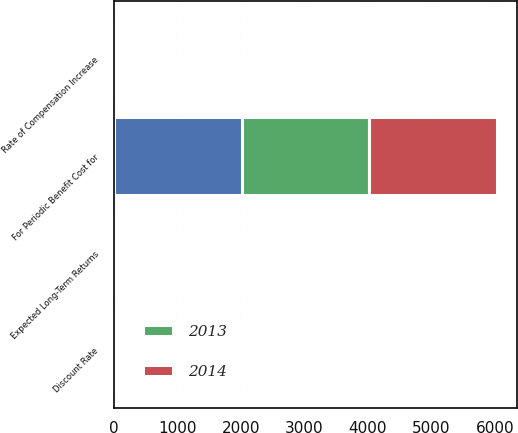Convert chart to OTSL. <chart><loc_0><loc_0><loc_500><loc_500><stacked_bar_chart><ecel><fcel>For Periodic Benefit Cost for<fcel>Discount Rate<fcel>Expected Long-Term Returns<fcel>Rate of Compensation Increase<nl><fcel>nan<fcel>2014<fcel>5.12<fcel>6.97<fcel>4.35<nl><fcel>2013<fcel>2013<fcel>4.18<fcel>6.96<fcel>4.4<nl><fcel>2014<fcel>2012<fcel>5.09<fcel>7.2<fcel>4.04<nl></chart> 